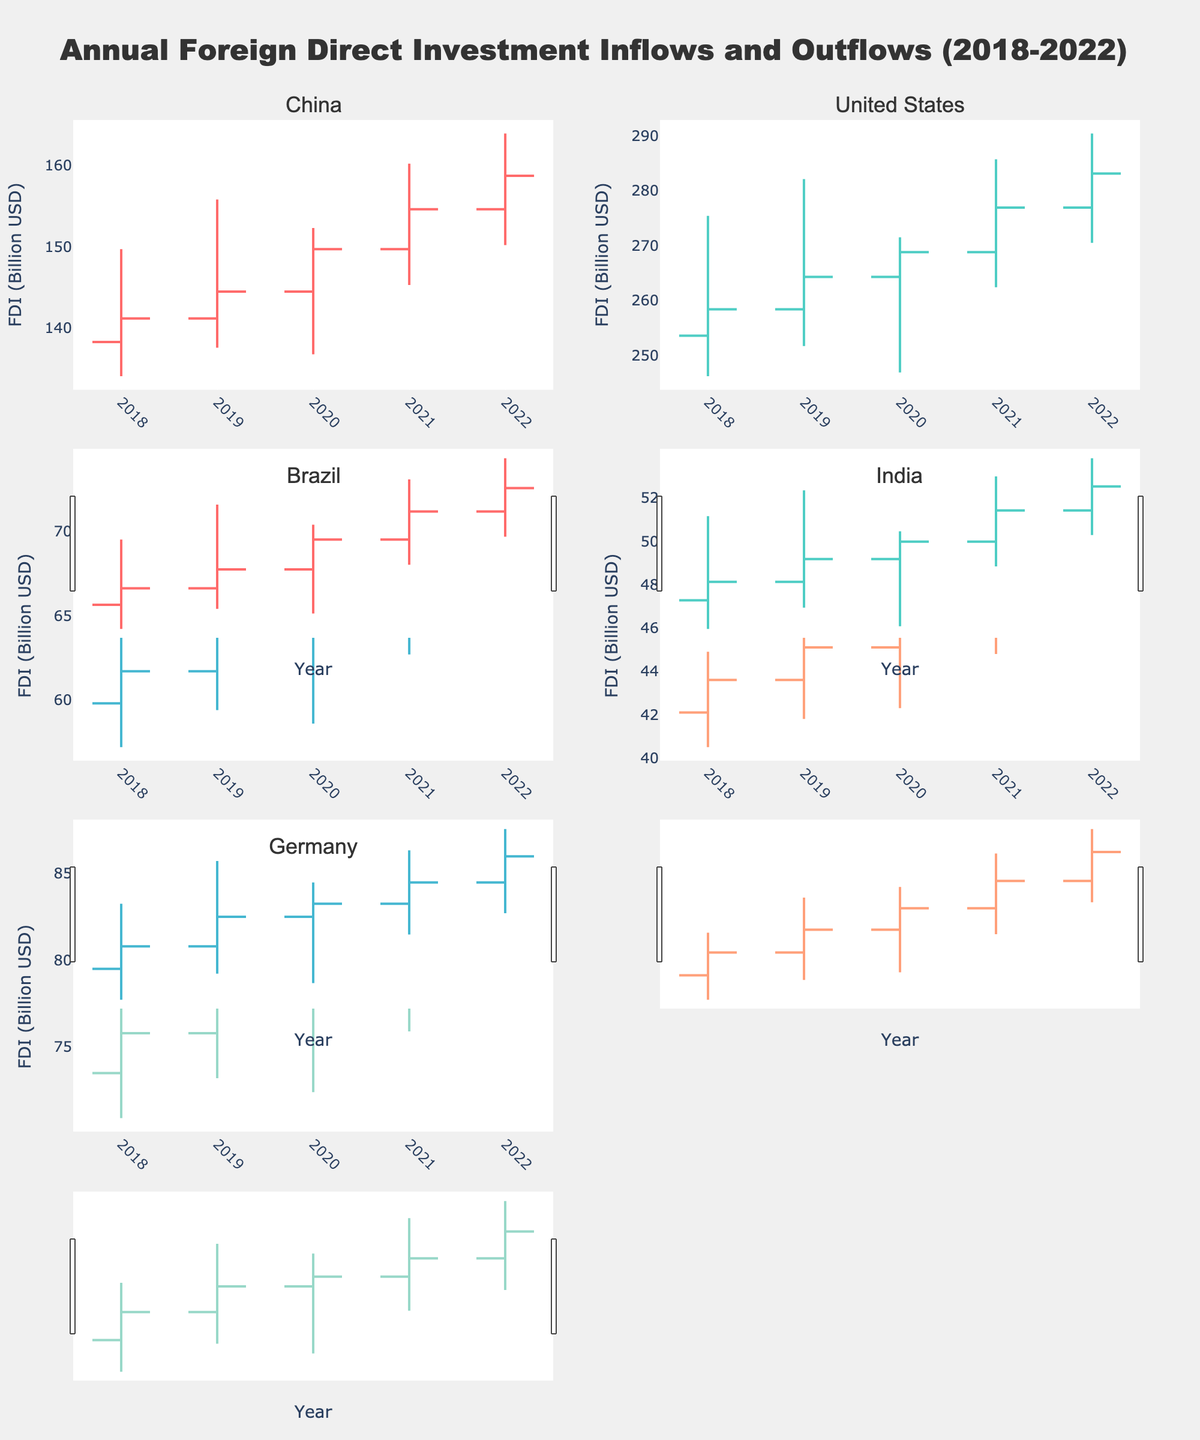What is the highest FDI inflow for China between 2018 and 2022? To find the highest FDI inflow for China, check the 'High' values for China across all years in the figure. The highest 'High' value for China is 163.9 billion USD in 2022.
Answer: 163.9 billion USD What was the FDI inflow for the United States in 2019? Look at the 'Close' values for the United States in 2019. The 'Close' value for that year is 264.3 billion USD.
Answer: 264.3 billion USD Which country had the lowest FDI inflow in 2021? To find the country with the lowest FDI inflow in 2021, look at all the 'Low' values for 2021 and identify the smallest. India's 'Low' value is the smallest at 44.8 billion USD.
Answer: India By how much did India's FDI inflow increase from 2018 to 2022? Calculate the difference between the 'Close' value for India in 2022 and 2018. The 'Close' value in 2018 is 43.6 billion USD, and in 2022 it is 50.2 billion USD. The difference is 50.2 - 43.6 = 6.6 billion USD.
Answer: 6.6 billion USD Which year did Germany see the highest volatility in its FDI inflow and outflow? Volatility can be assessed by finding the largest difference between 'High' and 'Low' values per year for Germany. In 2020, this difference was the highest with 80.6 - 72.4 = 8.2 billion USD.
Answer: 2020 Which country had the highest closing value of FDI in 2021? To find the highest closing value of FDI in 2021, compare the 'Close' values for all countries in that year. The United States had the highest closing value of 276.9 billion USD.
Answer: United States In which year did Brazil have the smallest range in its FDI inflow and outflow values? The range is calculated as the difference between 'High' and 'Low' values. For each year, compute this difference for Brazil: 
2018: 65.3 - 57.2 = 8.1,
2019: 68.9 - 59.4 = 9.5,
2020: 67.1 - 58.6 = 8.5,
2021: 69.8 - 62.7 = 7.1,
2022: 71.6 - 64.5 = 7.1.
The smallest range is in 2021 and 2022, both with a range of 7.1 billion USD.
Answer: 2021 and 2022 How did the FDI inflow for Germany change from 2019 to 2020? Comparing the 'Close' values for Germany in 2019 (77.9 billion USD) and 2020 (78.7 billion USD), the change is 78.7 - 77.9 = 0.8 billion USD.
Answer: Increased by 0.8 billion USD Which year saw the lowest FDI inflow for China between 2018 and 2022? Examine the 'Low' values for China across all years, and identify which year had the lowest value. The lowest FDI inflow for China was in 2020 with a 'Low' value of 136.8 billion USD.
Answer: 2020 